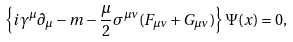<formula> <loc_0><loc_0><loc_500><loc_500>\left \{ i \gamma ^ { \mu } \partial _ { \mu } - m - \frac { \mu } { 2 } \sigma ^ { \mu \nu } ( F _ { \mu \nu } + G _ { \mu \nu } ) \right \} \Psi ( x ) = 0 ,</formula> 